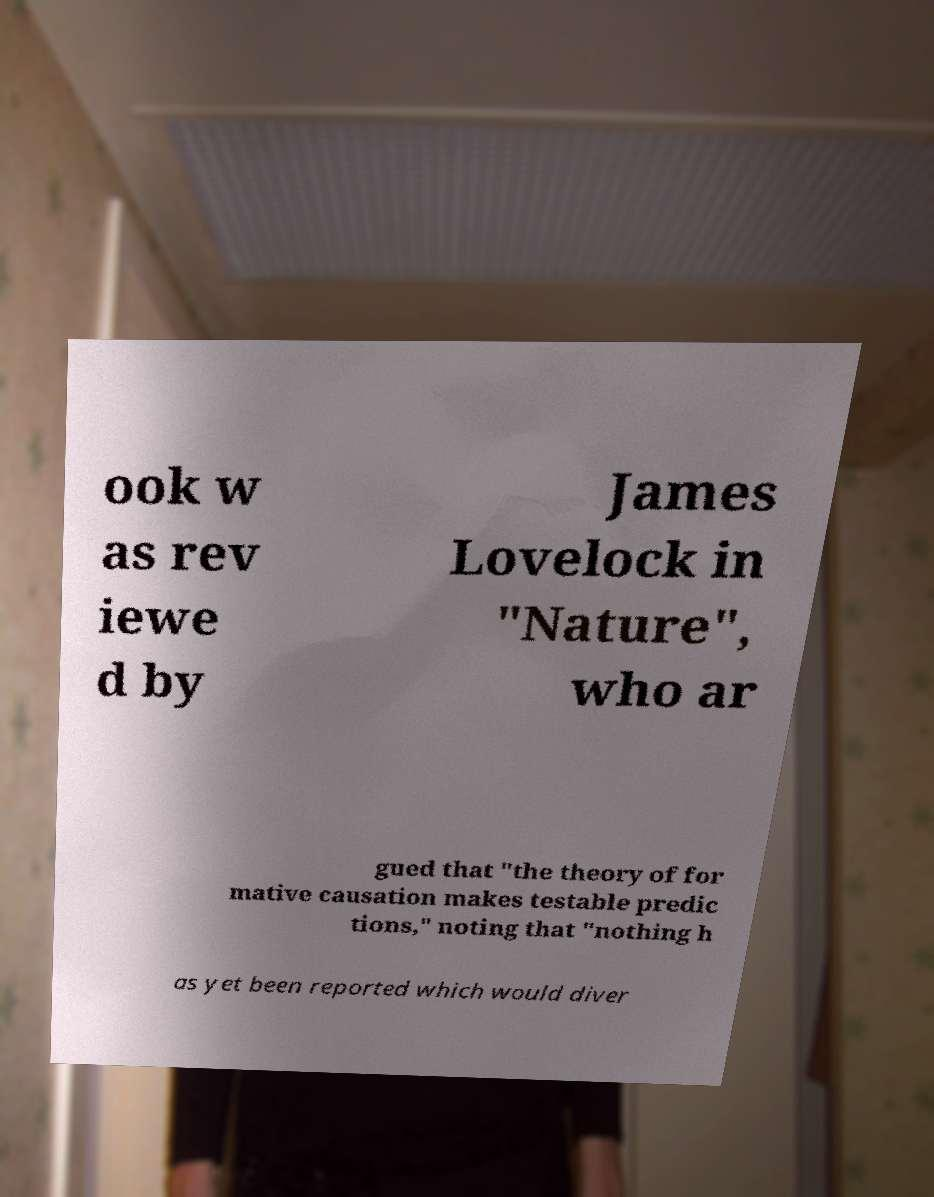Can you accurately transcribe the text from the provided image for me? ook w as rev iewe d by James Lovelock in "Nature", who ar gued that "the theory of for mative causation makes testable predic tions," noting that "nothing h as yet been reported which would diver 